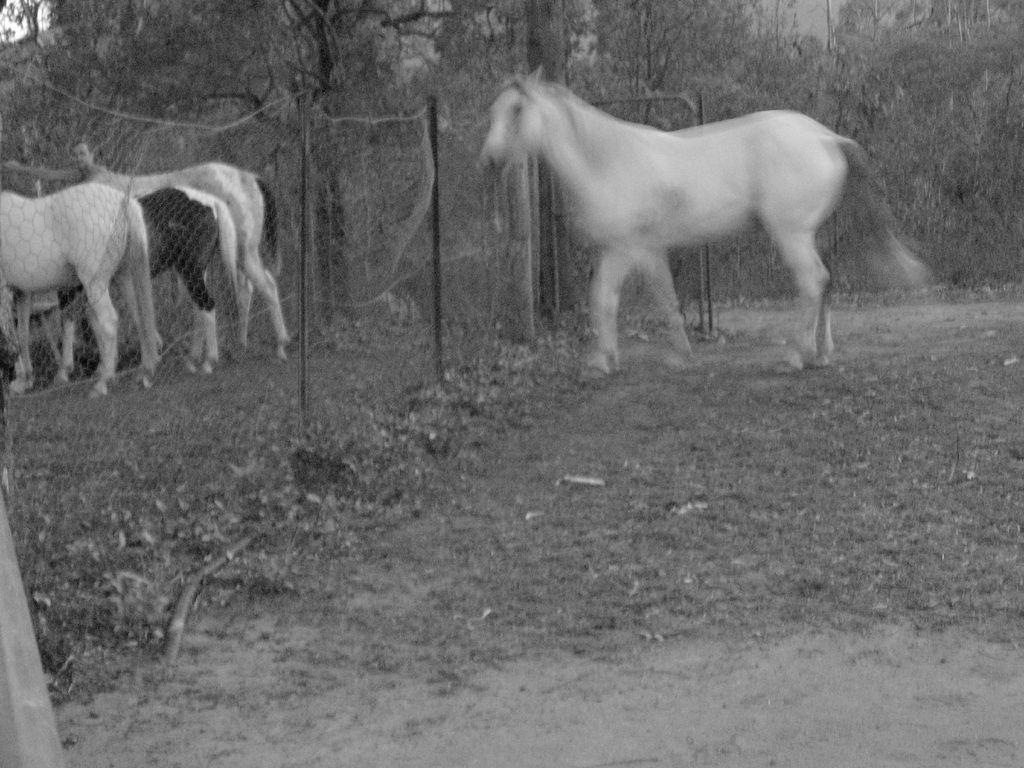What animal can be seen walking near a fencing wall in the image? There is a horse walking near a fencing wall in the image. Are there any other horses present in the image? Yes, there are other horses standing in the image. What can be seen in the background of the image? Trees are visible in the background of the image. How many babies are being carried by the horses in the image? There are no babies present in the image; only horses can be seen. 